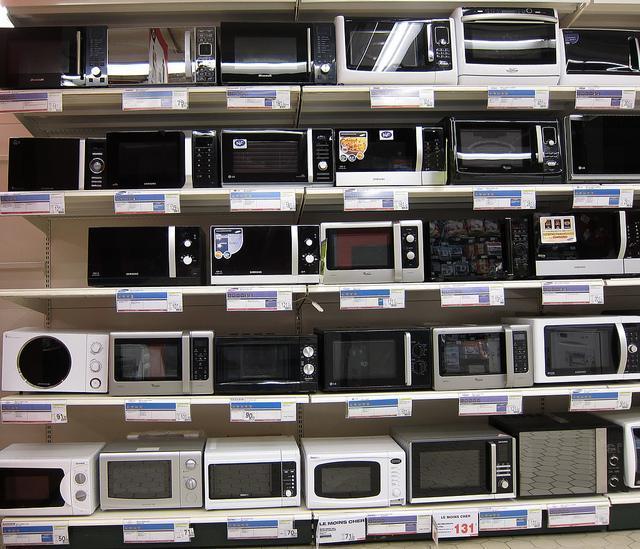How many shelves are there?
Give a very brief answer. 5. How many microwaves are visible?
Give a very brief answer. 13. 